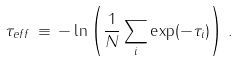Convert formula to latex. <formula><loc_0><loc_0><loc_500><loc_500>\tau _ { e f f } \, \equiv \, - \ln \left ( \frac { 1 } { N } \sum _ { i } \exp ( - \tau _ { i } ) \right ) \, .</formula> 